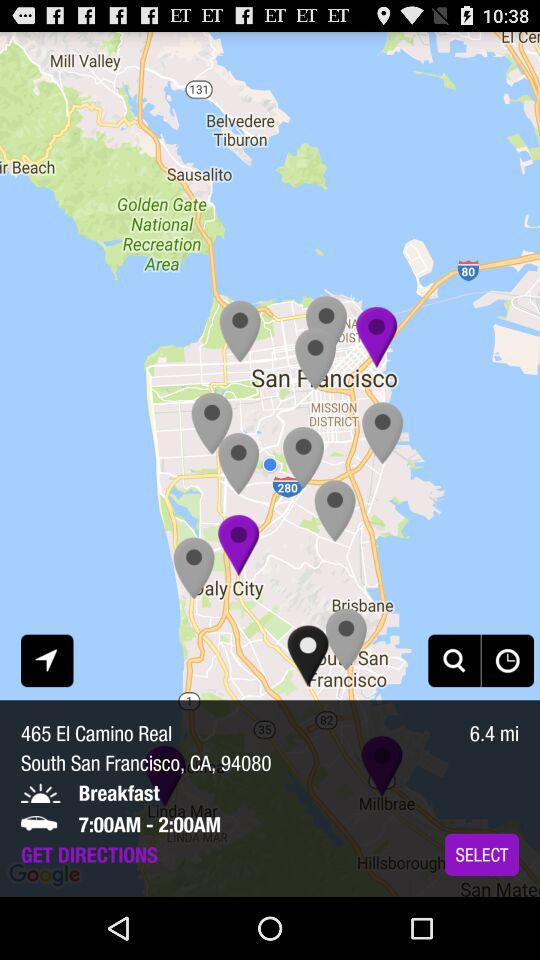What is the location? The location is 465 El Camino Real, South San Francisco, CA, 94080. 